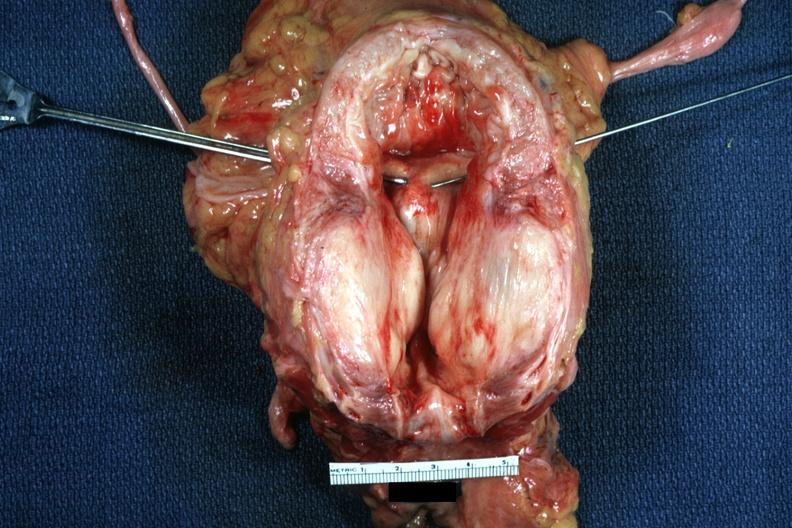what is present?
Answer the question using a single word or phrase. Prostate 